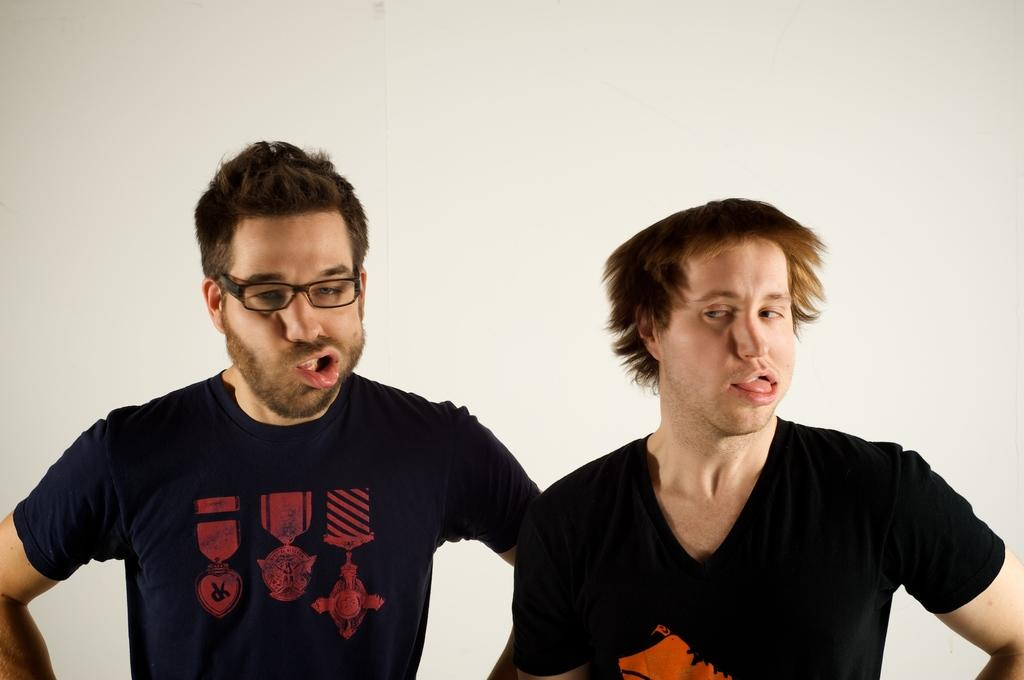How many people are in the image? There are two men in the image. What are the men doing in the image? Both men are making weird facial expressions. Can you describe the appearance of the man on the left side? The man on the left side is wearing spectacles. What is the price of the laborer's services in the image? There is no laborer present in the image, and therefore no services or prices to consider. 